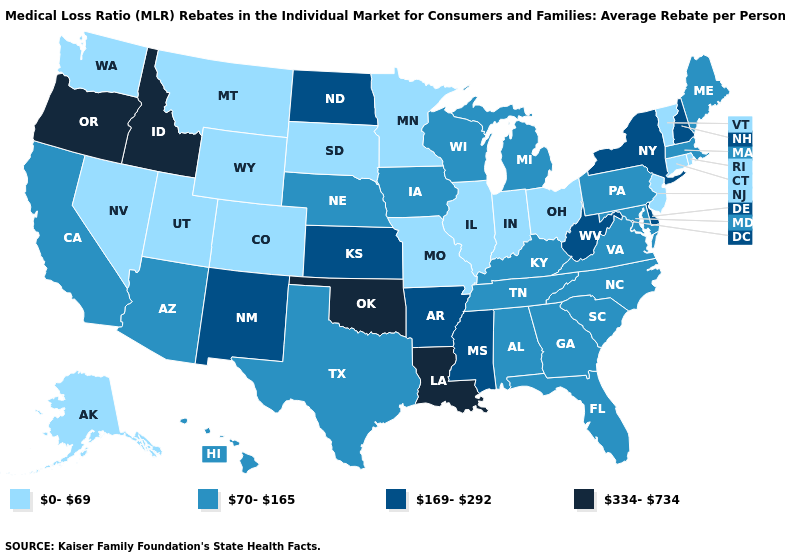What is the lowest value in states that border California?
Write a very short answer. 0-69. What is the value of Michigan?
Answer briefly. 70-165. Name the states that have a value in the range 0-69?
Write a very short answer. Alaska, Colorado, Connecticut, Illinois, Indiana, Minnesota, Missouri, Montana, Nevada, New Jersey, Ohio, Rhode Island, South Dakota, Utah, Vermont, Washington, Wyoming. Is the legend a continuous bar?
Be succinct. No. Does Idaho have the highest value in the West?
Quick response, please. Yes. Name the states that have a value in the range 70-165?
Answer briefly. Alabama, Arizona, California, Florida, Georgia, Hawaii, Iowa, Kentucky, Maine, Maryland, Massachusetts, Michigan, Nebraska, North Carolina, Pennsylvania, South Carolina, Tennessee, Texas, Virginia, Wisconsin. Name the states that have a value in the range 0-69?
Be succinct. Alaska, Colorado, Connecticut, Illinois, Indiana, Minnesota, Missouri, Montana, Nevada, New Jersey, Ohio, Rhode Island, South Dakota, Utah, Vermont, Washington, Wyoming. Name the states that have a value in the range 334-734?
Be succinct. Idaho, Louisiana, Oklahoma, Oregon. What is the value of Michigan?
Short answer required. 70-165. Does Pennsylvania have the lowest value in the Northeast?
Write a very short answer. No. Does Virginia have a higher value than Minnesota?
Answer briefly. Yes. What is the value of Mississippi?
Keep it brief. 169-292. How many symbols are there in the legend?
Keep it brief. 4. What is the lowest value in the USA?
Keep it brief. 0-69. 